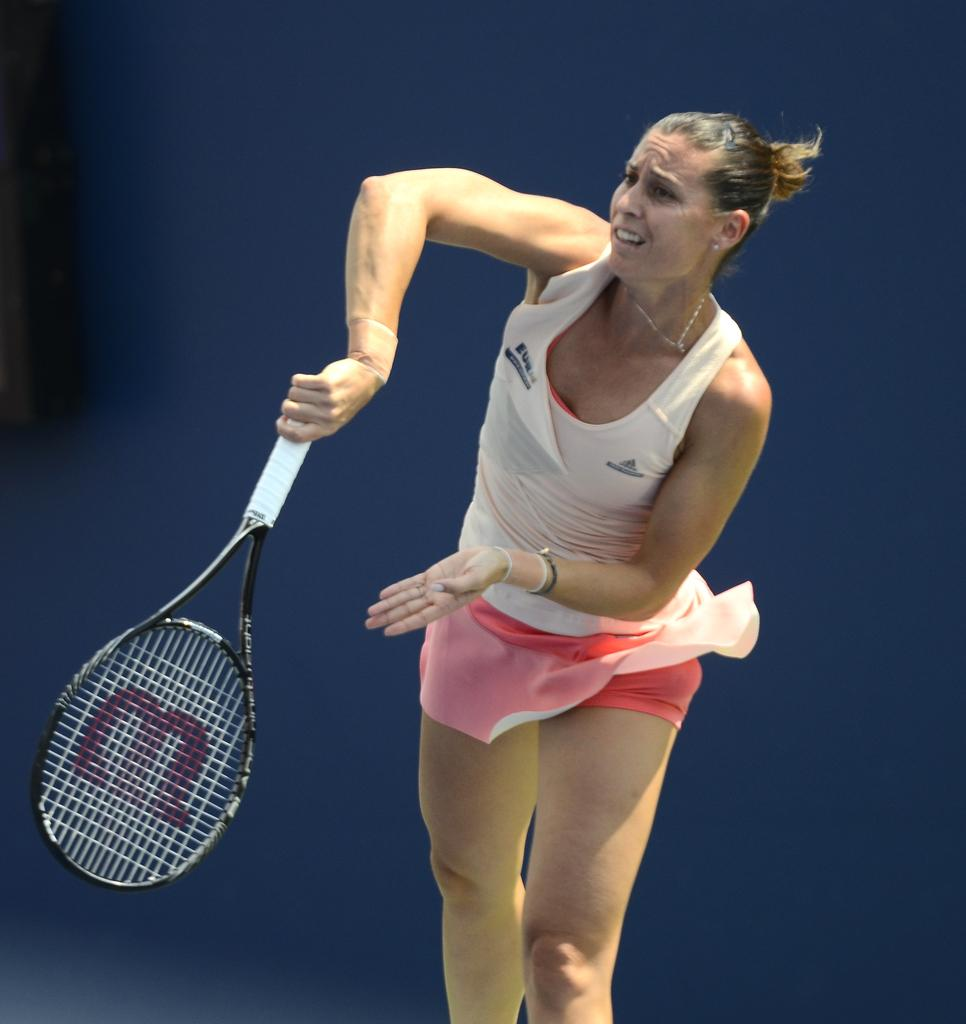Who is the main subject in the image? There is a woman in the image. What is the woman holding in the image? The woman is holding a tennis bat. What activity might the woman be engaged in, based on the image? The woman is likely playing tennis. What type of soup is the woman eating in the image? There is no soup present in the image; the woman is holding a tennis bat. 